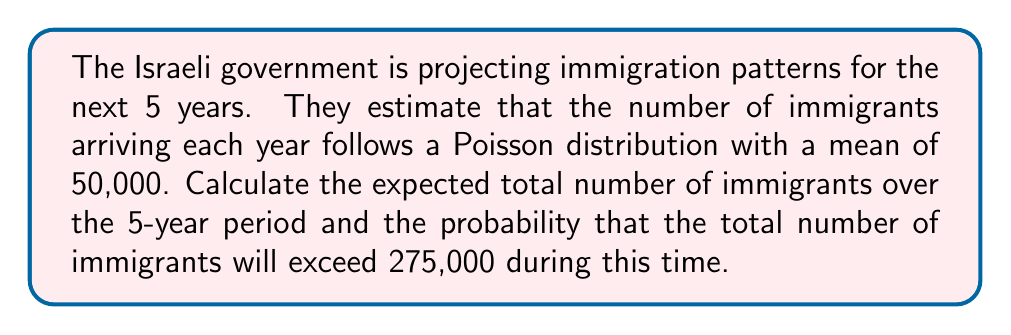Can you answer this question? Let's approach this step-by-step:

1) Let $X_i$ be the number of immigrants in year $i$, where $i = 1, 2, 3, 4, 5$.
   Each $X_i$ follows a Poisson distribution with $\lambda = 50,000$.

2) The total number of immigrants over 5 years, $Y = X_1 + X_2 + X_3 + X_4 + X_5$

3) Expected value of Y:
   $E(Y) = E(X_1 + X_2 + X_3 + X_4 + X_5)$
   $= E(X_1) + E(X_2) + E(X_3) + E(X_4) + E(X_5)$ (linearity of expectation)
   $= 50,000 + 50,000 + 50,000 + 50,000 + 50,000$
   $= 250,000$

4) For the probability calculation, we need to know the distribution of Y.
   The sum of independent Poisson random variables is also Poisson distributed.
   Therefore, Y follows a Poisson distribution with $\lambda = 5 * 50,000 = 250,000$

5) We need to calculate $P(Y > 275,000)$
   This is equivalent to $1 - P(Y \leq 275,000)$

6) Using the cumulative distribution function of the Poisson distribution:
   $P(Y \leq 275,000) = e^{-250000} \sum_{k=0}^{275000} \frac{250000^k}{k!}$

7) This can be approximated using the normal distribution as the Poisson parameter is large:
   $Y \sim N(250000, \sqrt{250000})$

8) Standardizing:
   $Z = \frac{275000 - 250000}{\sqrt{250000}} = 50$

9) Using the standard normal distribution:
   $P(Y > 275000) = 1 - P(Z < 50) \approx 0$

The probability is essentially zero (to many decimal places).
Answer: Expected total immigrants: 250,000. Probability of exceeding 275,000: $\approx 0$ 